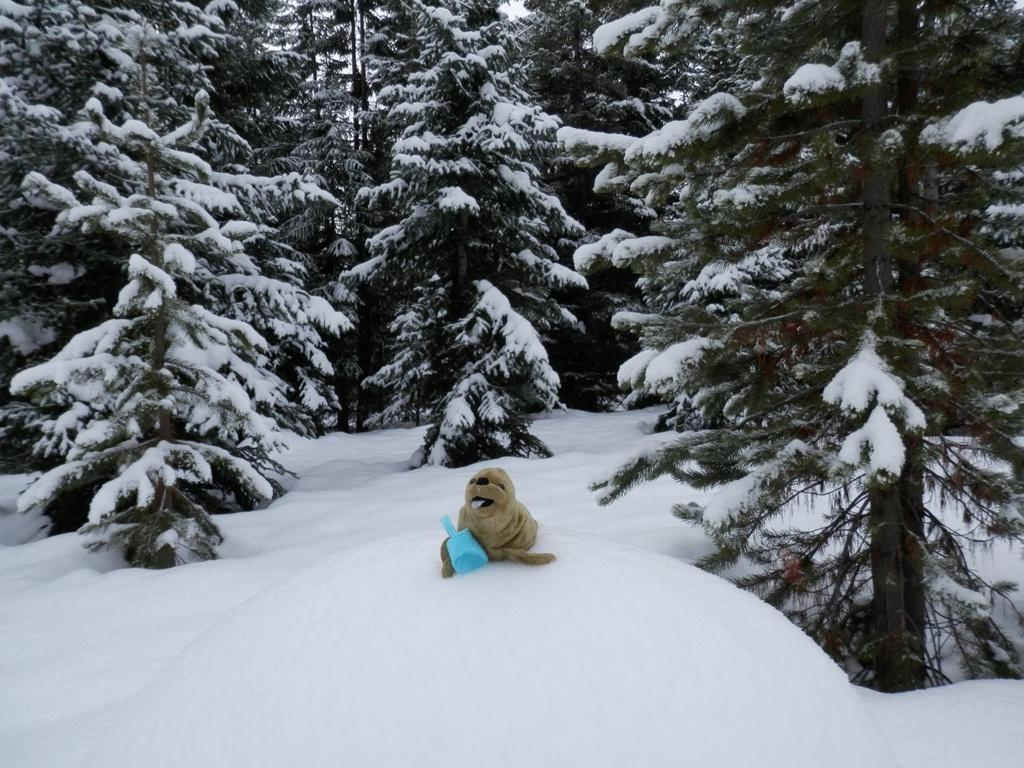What type of animal can be seen in the image? There is an animal in the image, but its specific type cannot be determined from the provided facts. Where is the animal located in the image? The animal is on the snow in the image. What color is the blue thing in the image? The blue color thing in the image cannot be described further without additional information. What can be seen in the background of the image? There are trees with snow in the background of the image. How many trucks are parked next to the animal in the image? There are no trucks present in the image; it features an animal on the snow with trees and snow in the background. 